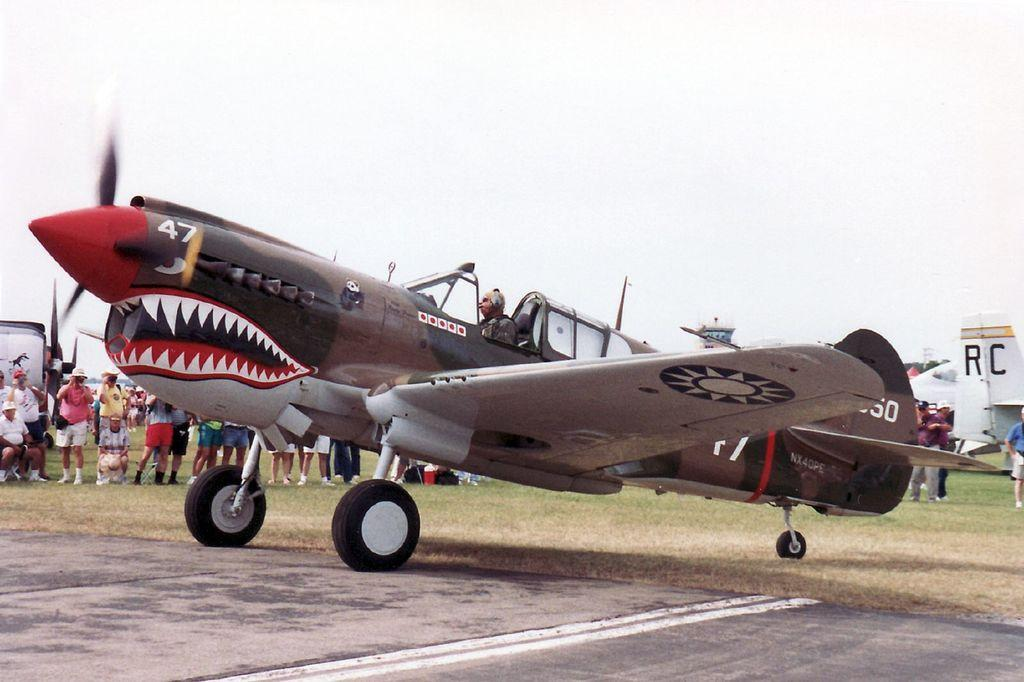<image>
Relay a brief, clear account of the picture shown. A plane has a mouth and teeth painted on it and the number 47. 